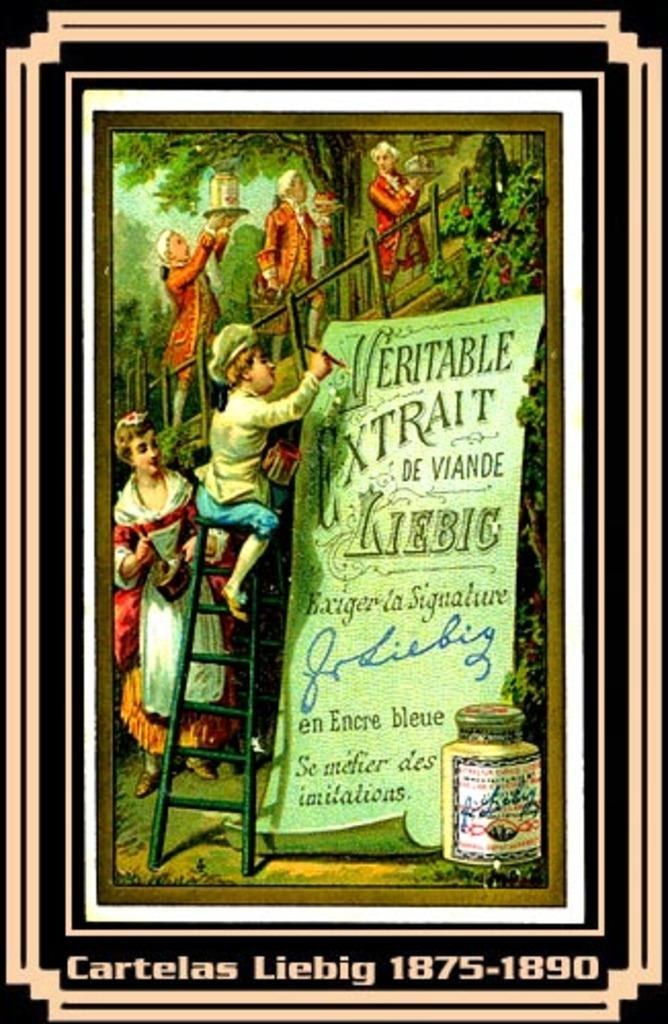What are the people in the image doing? The people in the image are walking. What is the person on the ladder doing? The person on the ladder is panting on a paper. What can be seen on the paper? Something is written on the paper. What type of vegetation is visible in the image? There are trees visible in the image. How many cows are visible in the image? There are no cows present in the image. What does the person on the ladder wish for while panting on the paper? There is no indication of a wish in the image, as the person on the ladder is panting on a paper with something written on it. 